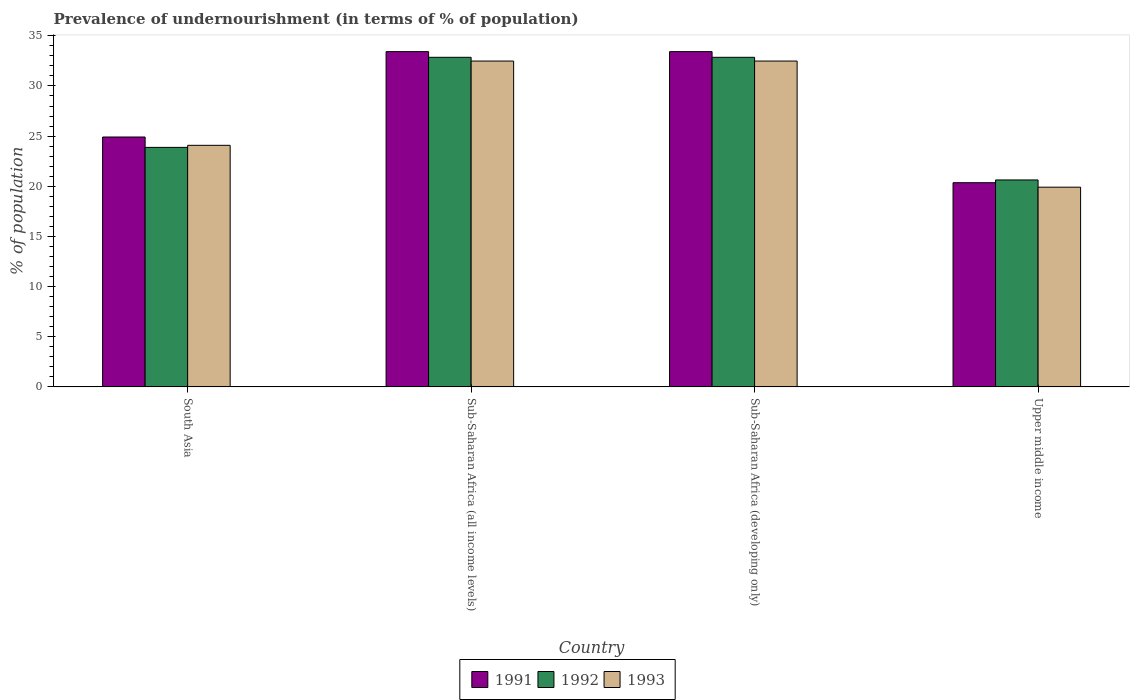How many different coloured bars are there?
Keep it short and to the point. 3. How many groups of bars are there?
Ensure brevity in your answer.  4. Are the number of bars per tick equal to the number of legend labels?
Provide a short and direct response. Yes. How many bars are there on the 4th tick from the left?
Make the answer very short. 3. How many bars are there on the 3rd tick from the right?
Offer a terse response. 3. What is the label of the 2nd group of bars from the left?
Provide a short and direct response. Sub-Saharan Africa (all income levels). What is the percentage of undernourished population in 1992 in South Asia?
Provide a succinct answer. 23.88. Across all countries, what is the maximum percentage of undernourished population in 1993?
Offer a very short reply. 32.48. Across all countries, what is the minimum percentage of undernourished population in 1993?
Keep it short and to the point. 19.91. In which country was the percentage of undernourished population in 1993 maximum?
Give a very brief answer. Sub-Saharan Africa (all income levels). In which country was the percentage of undernourished population in 1992 minimum?
Provide a short and direct response. Upper middle income. What is the total percentage of undernourished population in 1993 in the graph?
Your answer should be compact. 108.95. What is the difference between the percentage of undernourished population in 1991 in Sub-Saharan Africa (developing only) and that in Upper middle income?
Make the answer very short. 13.07. What is the difference between the percentage of undernourished population in 1993 in Sub-Saharan Africa (developing only) and the percentage of undernourished population in 1991 in South Asia?
Your answer should be compact. 7.57. What is the average percentage of undernourished population in 1992 per country?
Offer a terse response. 27.55. What is the difference between the percentage of undernourished population of/in 1991 and percentage of undernourished population of/in 1992 in Sub-Saharan Africa (all income levels)?
Make the answer very short. 0.57. What is the ratio of the percentage of undernourished population in 1993 in South Asia to that in Sub-Saharan Africa (developing only)?
Your answer should be very brief. 0.74. Is the percentage of undernourished population in 1993 in South Asia less than that in Upper middle income?
Your response must be concise. No. Is the difference between the percentage of undernourished population in 1991 in Sub-Saharan Africa (all income levels) and Upper middle income greater than the difference between the percentage of undernourished population in 1992 in Sub-Saharan Africa (all income levels) and Upper middle income?
Offer a very short reply. Yes. What is the difference between the highest and the second highest percentage of undernourished population in 1993?
Your answer should be very brief. 8.4. What is the difference between the highest and the lowest percentage of undernourished population in 1991?
Keep it short and to the point. 13.07. In how many countries, is the percentage of undernourished population in 1993 greater than the average percentage of undernourished population in 1993 taken over all countries?
Make the answer very short. 2. Is the sum of the percentage of undernourished population in 1991 in South Asia and Sub-Saharan Africa (all income levels) greater than the maximum percentage of undernourished population in 1993 across all countries?
Give a very brief answer. Yes. What does the 3rd bar from the left in South Asia represents?
Make the answer very short. 1993. Is it the case that in every country, the sum of the percentage of undernourished population in 1993 and percentage of undernourished population in 1991 is greater than the percentage of undernourished population in 1992?
Make the answer very short. Yes. How many bars are there?
Offer a very short reply. 12. Are all the bars in the graph horizontal?
Provide a short and direct response. No. How many countries are there in the graph?
Your answer should be very brief. 4. What is the difference between two consecutive major ticks on the Y-axis?
Provide a short and direct response. 5. Are the values on the major ticks of Y-axis written in scientific E-notation?
Keep it short and to the point. No. Does the graph contain any zero values?
Your answer should be very brief. No. Does the graph contain grids?
Your response must be concise. No. How many legend labels are there?
Keep it short and to the point. 3. How are the legend labels stacked?
Your answer should be very brief. Horizontal. What is the title of the graph?
Your answer should be very brief. Prevalence of undernourishment (in terms of % of population). What is the label or title of the X-axis?
Ensure brevity in your answer.  Country. What is the label or title of the Y-axis?
Your answer should be very brief. % of population. What is the % of population of 1991 in South Asia?
Keep it short and to the point. 24.91. What is the % of population of 1992 in South Asia?
Make the answer very short. 23.88. What is the % of population of 1993 in South Asia?
Keep it short and to the point. 24.08. What is the % of population in 1991 in Sub-Saharan Africa (all income levels)?
Your answer should be very brief. 33.42. What is the % of population of 1992 in Sub-Saharan Africa (all income levels)?
Provide a succinct answer. 32.86. What is the % of population of 1993 in Sub-Saharan Africa (all income levels)?
Give a very brief answer. 32.48. What is the % of population of 1991 in Sub-Saharan Africa (developing only)?
Make the answer very short. 33.42. What is the % of population in 1992 in Sub-Saharan Africa (developing only)?
Offer a terse response. 32.86. What is the % of population in 1993 in Sub-Saharan Africa (developing only)?
Provide a succinct answer. 32.48. What is the % of population in 1991 in Upper middle income?
Provide a short and direct response. 20.35. What is the % of population in 1992 in Upper middle income?
Give a very brief answer. 20.63. What is the % of population of 1993 in Upper middle income?
Offer a terse response. 19.91. Across all countries, what is the maximum % of population in 1991?
Ensure brevity in your answer.  33.42. Across all countries, what is the maximum % of population of 1992?
Keep it short and to the point. 32.86. Across all countries, what is the maximum % of population in 1993?
Provide a short and direct response. 32.48. Across all countries, what is the minimum % of population of 1991?
Keep it short and to the point. 20.35. Across all countries, what is the minimum % of population of 1992?
Offer a terse response. 20.63. Across all countries, what is the minimum % of population in 1993?
Your response must be concise. 19.91. What is the total % of population of 1991 in the graph?
Your response must be concise. 112.11. What is the total % of population in 1992 in the graph?
Ensure brevity in your answer.  110.22. What is the total % of population of 1993 in the graph?
Make the answer very short. 108.95. What is the difference between the % of population of 1991 in South Asia and that in Sub-Saharan Africa (all income levels)?
Ensure brevity in your answer.  -8.51. What is the difference between the % of population of 1992 in South Asia and that in Sub-Saharan Africa (all income levels)?
Offer a very short reply. -8.98. What is the difference between the % of population in 1993 in South Asia and that in Sub-Saharan Africa (all income levels)?
Offer a terse response. -8.4. What is the difference between the % of population of 1991 in South Asia and that in Sub-Saharan Africa (developing only)?
Offer a very short reply. -8.51. What is the difference between the % of population of 1992 in South Asia and that in Sub-Saharan Africa (developing only)?
Give a very brief answer. -8.98. What is the difference between the % of population in 1993 in South Asia and that in Sub-Saharan Africa (developing only)?
Keep it short and to the point. -8.4. What is the difference between the % of population in 1991 in South Asia and that in Upper middle income?
Your answer should be compact. 4.56. What is the difference between the % of population in 1992 in South Asia and that in Upper middle income?
Your answer should be compact. 3.25. What is the difference between the % of population in 1993 in South Asia and that in Upper middle income?
Your answer should be compact. 4.17. What is the difference between the % of population of 1992 in Sub-Saharan Africa (all income levels) and that in Sub-Saharan Africa (developing only)?
Make the answer very short. 0. What is the difference between the % of population in 1991 in Sub-Saharan Africa (all income levels) and that in Upper middle income?
Offer a terse response. 13.07. What is the difference between the % of population of 1992 in Sub-Saharan Africa (all income levels) and that in Upper middle income?
Make the answer very short. 12.23. What is the difference between the % of population of 1993 in Sub-Saharan Africa (all income levels) and that in Upper middle income?
Ensure brevity in your answer.  12.58. What is the difference between the % of population in 1991 in Sub-Saharan Africa (developing only) and that in Upper middle income?
Your answer should be very brief. 13.07. What is the difference between the % of population in 1992 in Sub-Saharan Africa (developing only) and that in Upper middle income?
Your response must be concise. 12.23. What is the difference between the % of population of 1993 in Sub-Saharan Africa (developing only) and that in Upper middle income?
Offer a very short reply. 12.58. What is the difference between the % of population in 1991 in South Asia and the % of population in 1992 in Sub-Saharan Africa (all income levels)?
Provide a short and direct response. -7.95. What is the difference between the % of population of 1991 in South Asia and the % of population of 1993 in Sub-Saharan Africa (all income levels)?
Give a very brief answer. -7.57. What is the difference between the % of population in 1992 in South Asia and the % of population in 1993 in Sub-Saharan Africa (all income levels)?
Keep it short and to the point. -8.61. What is the difference between the % of population of 1991 in South Asia and the % of population of 1992 in Sub-Saharan Africa (developing only)?
Your response must be concise. -7.95. What is the difference between the % of population in 1991 in South Asia and the % of population in 1993 in Sub-Saharan Africa (developing only)?
Offer a very short reply. -7.57. What is the difference between the % of population in 1992 in South Asia and the % of population in 1993 in Sub-Saharan Africa (developing only)?
Give a very brief answer. -8.61. What is the difference between the % of population of 1991 in South Asia and the % of population of 1992 in Upper middle income?
Keep it short and to the point. 4.28. What is the difference between the % of population in 1991 in South Asia and the % of population in 1993 in Upper middle income?
Offer a terse response. 5. What is the difference between the % of population in 1992 in South Asia and the % of population in 1993 in Upper middle income?
Your response must be concise. 3.97. What is the difference between the % of population of 1991 in Sub-Saharan Africa (all income levels) and the % of population of 1992 in Sub-Saharan Africa (developing only)?
Give a very brief answer. 0.57. What is the difference between the % of population in 1991 in Sub-Saharan Africa (all income levels) and the % of population in 1993 in Sub-Saharan Africa (developing only)?
Your answer should be compact. 0.94. What is the difference between the % of population of 1992 in Sub-Saharan Africa (all income levels) and the % of population of 1993 in Sub-Saharan Africa (developing only)?
Your answer should be compact. 0.37. What is the difference between the % of population in 1991 in Sub-Saharan Africa (all income levels) and the % of population in 1992 in Upper middle income?
Offer a very short reply. 12.79. What is the difference between the % of population in 1991 in Sub-Saharan Africa (all income levels) and the % of population in 1993 in Upper middle income?
Offer a very short reply. 13.51. What is the difference between the % of population in 1992 in Sub-Saharan Africa (all income levels) and the % of population in 1993 in Upper middle income?
Make the answer very short. 12.95. What is the difference between the % of population of 1991 in Sub-Saharan Africa (developing only) and the % of population of 1992 in Upper middle income?
Your response must be concise. 12.79. What is the difference between the % of population of 1991 in Sub-Saharan Africa (developing only) and the % of population of 1993 in Upper middle income?
Make the answer very short. 13.51. What is the difference between the % of population of 1992 in Sub-Saharan Africa (developing only) and the % of population of 1993 in Upper middle income?
Your answer should be very brief. 12.95. What is the average % of population in 1991 per country?
Ensure brevity in your answer.  28.03. What is the average % of population of 1992 per country?
Offer a very short reply. 27.55. What is the average % of population of 1993 per country?
Give a very brief answer. 27.24. What is the difference between the % of population of 1991 and % of population of 1992 in South Asia?
Your answer should be compact. 1.04. What is the difference between the % of population of 1991 and % of population of 1993 in South Asia?
Your answer should be compact. 0.83. What is the difference between the % of population of 1992 and % of population of 1993 in South Asia?
Your answer should be very brief. -0.21. What is the difference between the % of population of 1991 and % of population of 1992 in Sub-Saharan Africa (all income levels)?
Provide a succinct answer. 0.57. What is the difference between the % of population in 1991 and % of population in 1993 in Sub-Saharan Africa (all income levels)?
Make the answer very short. 0.94. What is the difference between the % of population of 1992 and % of population of 1993 in Sub-Saharan Africa (all income levels)?
Ensure brevity in your answer.  0.37. What is the difference between the % of population of 1991 and % of population of 1992 in Sub-Saharan Africa (developing only)?
Provide a short and direct response. 0.57. What is the difference between the % of population of 1991 and % of population of 1993 in Sub-Saharan Africa (developing only)?
Your answer should be compact. 0.94. What is the difference between the % of population in 1992 and % of population in 1993 in Sub-Saharan Africa (developing only)?
Make the answer very short. 0.37. What is the difference between the % of population of 1991 and % of population of 1992 in Upper middle income?
Offer a very short reply. -0.28. What is the difference between the % of population of 1991 and % of population of 1993 in Upper middle income?
Offer a very short reply. 0.45. What is the difference between the % of population of 1992 and % of population of 1993 in Upper middle income?
Provide a succinct answer. 0.72. What is the ratio of the % of population in 1991 in South Asia to that in Sub-Saharan Africa (all income levels)?
Provide a short and direct response. 0.75. What is the ratio of the % of population of 1992 in South Asia to that in Sub-Saharan Africa (all income levels)?
Keep it short and to the point. 0.73. What is the ratio of the % of population in 1993 in South Asia to that in Sub-Saharan Africa (all income levels)?
Your answer should be very brief. 0.74. What is the ratio of the % of population in 1991 in South Asia to that in Sub-Saharan Africa (developing only)?
Provide a short and direct response. 0.75. What is the ratio of the % of population in 1992 in South Asia to that in Sub-Saharan Africa (developing only)?
Make the answer very short. 0.73. What is the ratio of the % of population in 1993 in South Asia to that in Sub-Saharan Africa (developing only)?
Offer a terse response. 0.74. What is the ratio of the % of population of 1991 in South Asia to that in Upper middle income?
Your response must be concise. 1.22. What is the ratio of the % of population of 1992 in South Asia to that in Upper middle income?
Offer a terse response. 1.16. What is the ratio of the % of population of 1993 in South Asia to that in Upper middle income?
Offer a terse response. 1.21. What is the ratio of the % of population in 1993 in Sub-Saharan Africa (all income levels) to that in Sub-Saharan Africa (developing only)?
Your response must be concise. 1. What is the ratio of the % of population of 1991 in Sub-Saharan Africa (all income levels) to that in Upper middle income?
Make the answer very short. 1.64. What is the ratio of the % of population of 1992 in Sub-Saharan Africa (all income levels) to that in Upper middle income?
Ensure brevity in your answer.  1.59. What is the ratio of the % of population in 1993 in Sub-Saharan Africa (all income levels) to that in Upper middle income?
Your answer should be very brief. 1.63. What is the ratio of the % of population of 1991 in Sub-Saharan Africa (developing only) to that in Upper middle income?
Provide a short and direct response. 1.64. What is the ratio of the % of population in 1992 in Sub-Saharan Africa (developing only) to that in Upper middle income?
Your response must be concise. 1.59. What is the ratio of the % of population of 1993 in Sub-Saharan Africa (developing only) to that in Upper middle income?
Make the answer very short. 1.63. What is the difference between the highest and the second highest % of population of 1993?
Provide a short and direct response. 0. What is the difference between the highest and the lowest % of population in 1991?
Offer a terse response. 13.07. What is the difference between the highest and the lowest % of population of 1992?
Provide a short and direct response. 12.23. What is the difference between the highest and the lowest % of population in 1993?
Give a very brief answer. 12.58. 